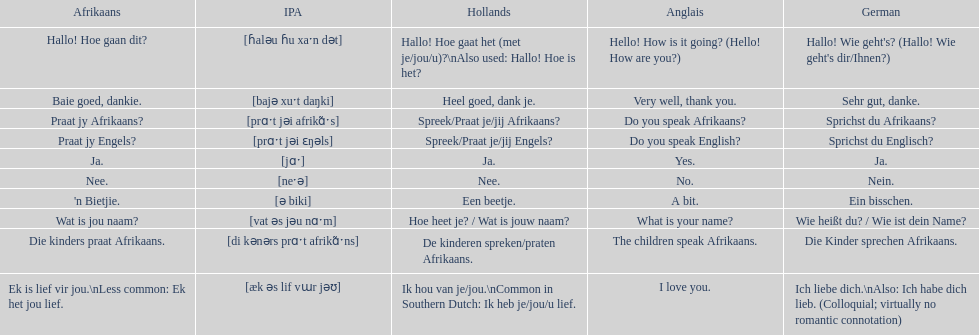How do you say 'do you speak afrikaans?' in afrikaans? Praat jy Afrikaans?. 